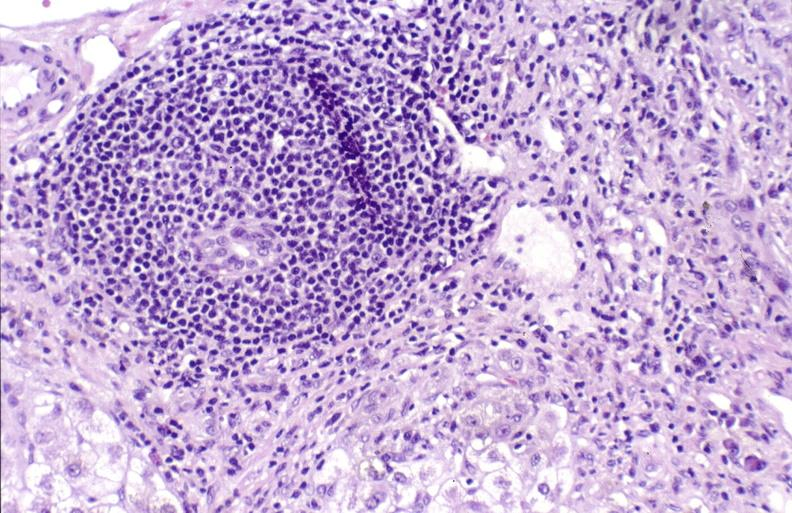what does this image show?
Answer the question using a single word or phrase. Primary biliary cirrhosis 